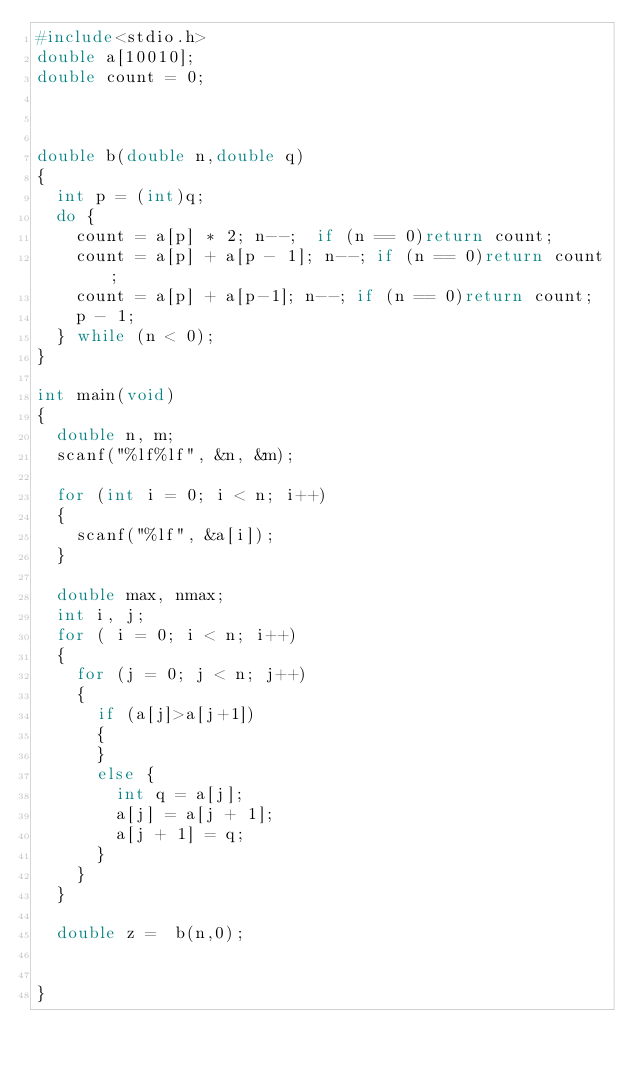<code> <loc_0><loc_0><loc_500><loc_500><_C_>#include<stdio.h>
double a[10010];
double count = 0;



double b(double n,double q)
{
	int p = (int)q;
	do {
		count = a[p] * 2; n--;	if (n == 0)return count;
		count = a[p] + a[p - 1]; n--;	if (n == 0)return count;
		count = a[p] + a[p-1]; n--; if (n == 0)return count;
		p - 1;
	} while (n < 0);
}

int main(void)
{		
	double n, m;
	scanf("%lf%lf", &n, &m);

	for (int i = 0; i < n; i++)
	{
		scanf("%lf", &a[i]);
	}

	double max, nmax;
	int i, j;
	for ( i = 0; i < n; i++)
	{
		for (j = 0; j < n; j++)
		{
			if (a[j]>a[j+1])
			{
			}
			else {
				int q = a[j];
				a[j] = a[j + 1];
				a[j + 1] = q;
			}
		}
	}

	double z =	b(n,0);


}</code> 